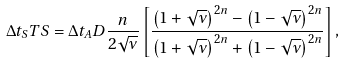<formula> <loc_0><loc_0><loc_500><loc_500>\Delta t _ { S } T S = \Delta t _ { A } D \frac { n } { 2 \sqrt { \nu } } \left [ \frac { \left ( 1 + \sqrt { \nu } \right ) ^ { 2 n } - \left ( 1 - \sqrt { \nu } \right ) ^ { 2 n } } { \left ( 1 + \sqrt { \nu } \right ) ^ { 2 n } + \left ( 1 - \sqrt { \nu } \right ) ^ { 2 n } } \right ] ,</formula> 